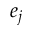Convert formula to latex. <formula><loc_0><loc_0><loc_500><loc_500>e _ { j }</formula> 